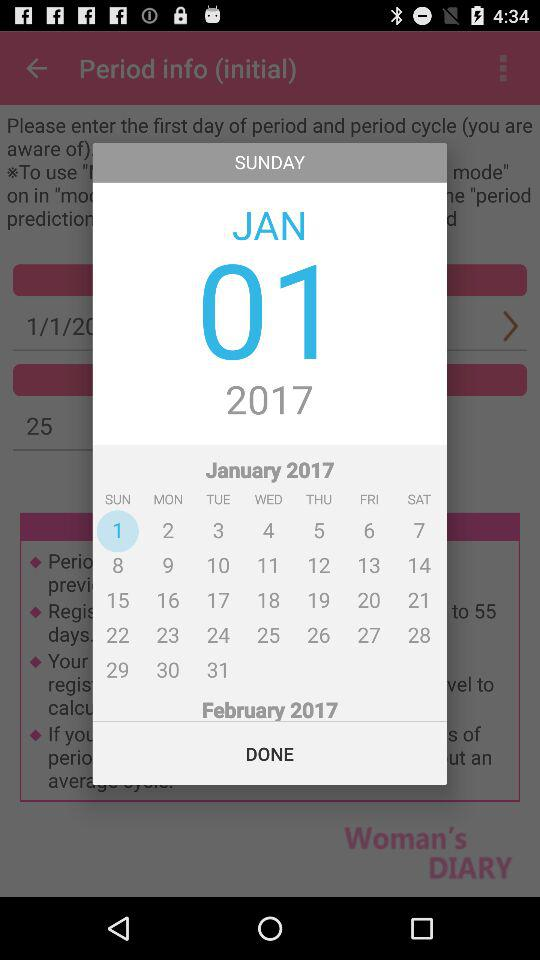What is the day on the 1st of January? The day on the 1st of January is "SUNDAY". 